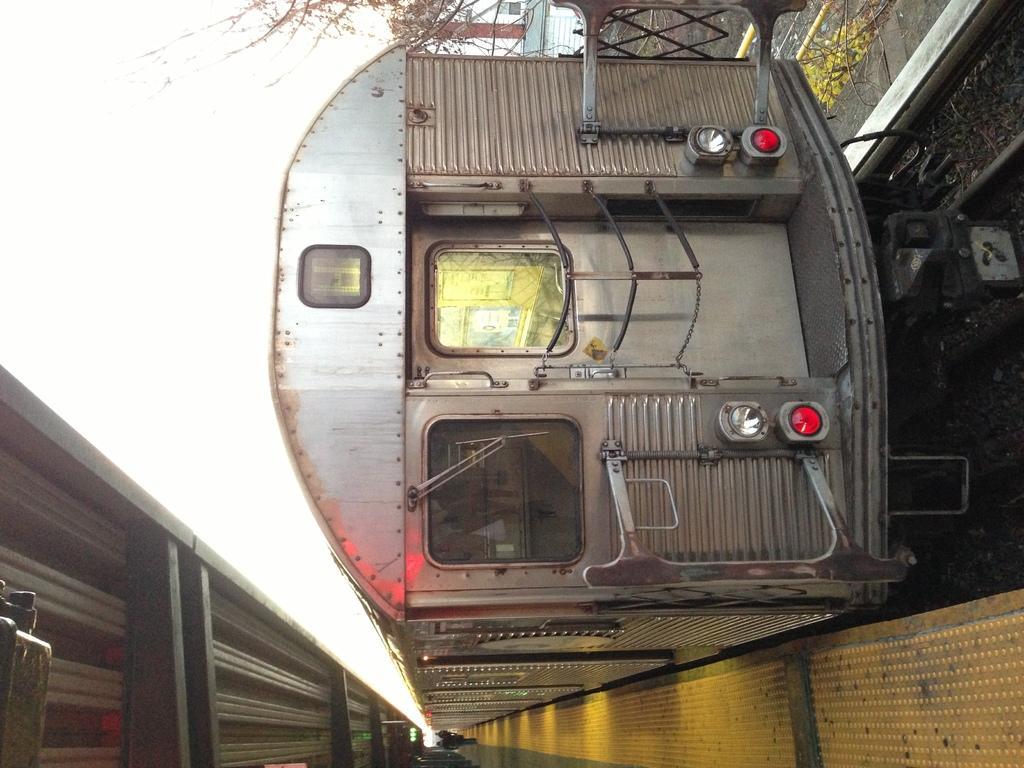Could you give a brief overview of what you see in this image? In this picture we can see a train on the track, beside to it we can see trees and few people. 